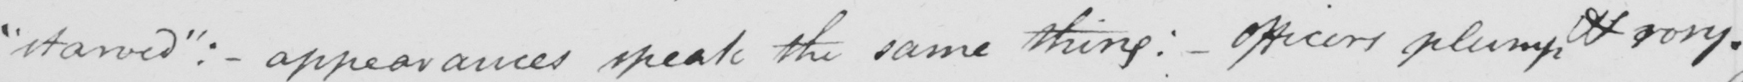What does this handwritten line say? " starved "  :   _  appearances speak the same thing :   _  officers plump & rosy . 